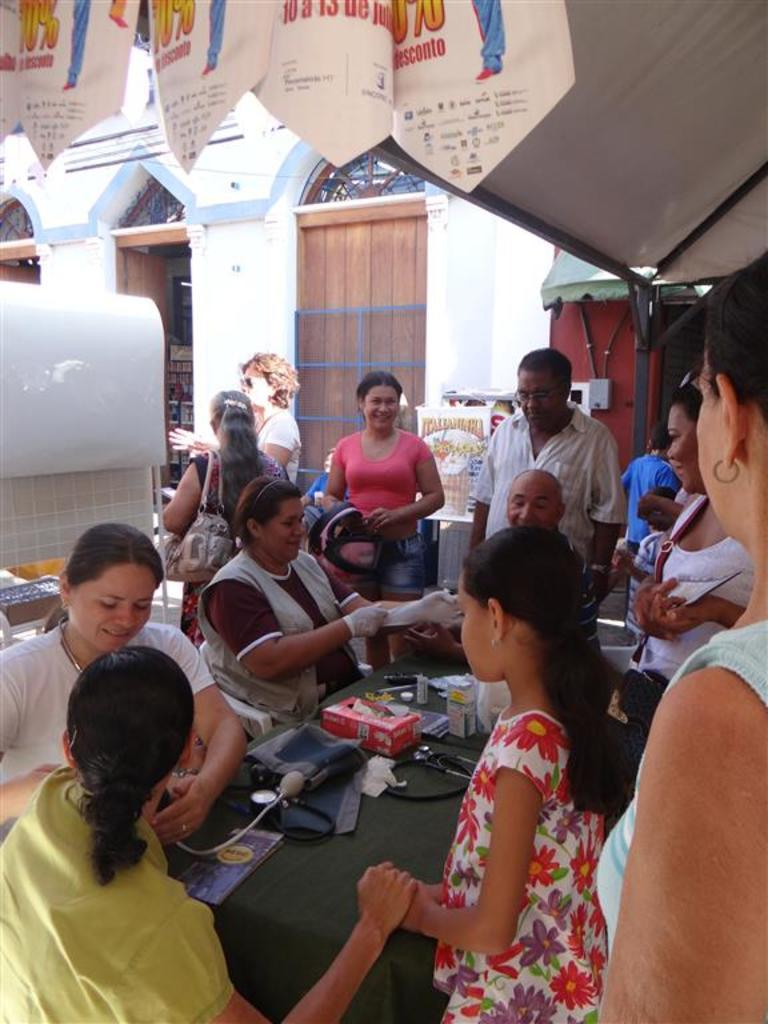How many people are in the image? There are two ladies in the image. What are the ladies doing in the image? The ladies are giving treatment to people. What are the ladies sitting on while providing treatment? The ladies are sitting on chairs. What type of heat source can be seen in the image? There is no heat source visible in the image. What is the ladies' occupation, as indicated by the presence of lead in the image? There is no mention of lead or any occupation-related details in the image. 